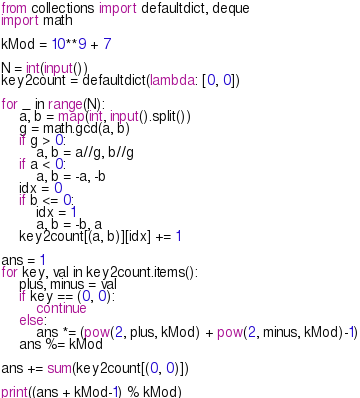Convert code to text. <code><loc_0><loc_0><loc_500><loc_500><_Python_>from collections import defaultdict, deque
import math

kMod = 10**9 + 7

N = int(input())
key2count = defaultdict(lambda: [0, 0])

for _ in range(N):
    a, b = map(int, input().split())
    g = math.gcd(a, b)
    if g > 0:
        a, b = a//g, b//g
    if a < 0:
        a, b = -a, -b
    idx = 0
    if b <= 0:
        idx = 1
        a, b = -b, a
    key2count[(a, b)][idx] += 1

ans = 1
for key, val in key2count.items():
    plus, minus = val
    if key == (0, 0):
        continue
    else:
        ans *= (pow(2, plus, kMod) + pow(2, minus, kMod)-1)
    ans %= kMod

ans += sum(key2count[(0, 0)])

print((ans + kMod-1) % kMod)</code> 